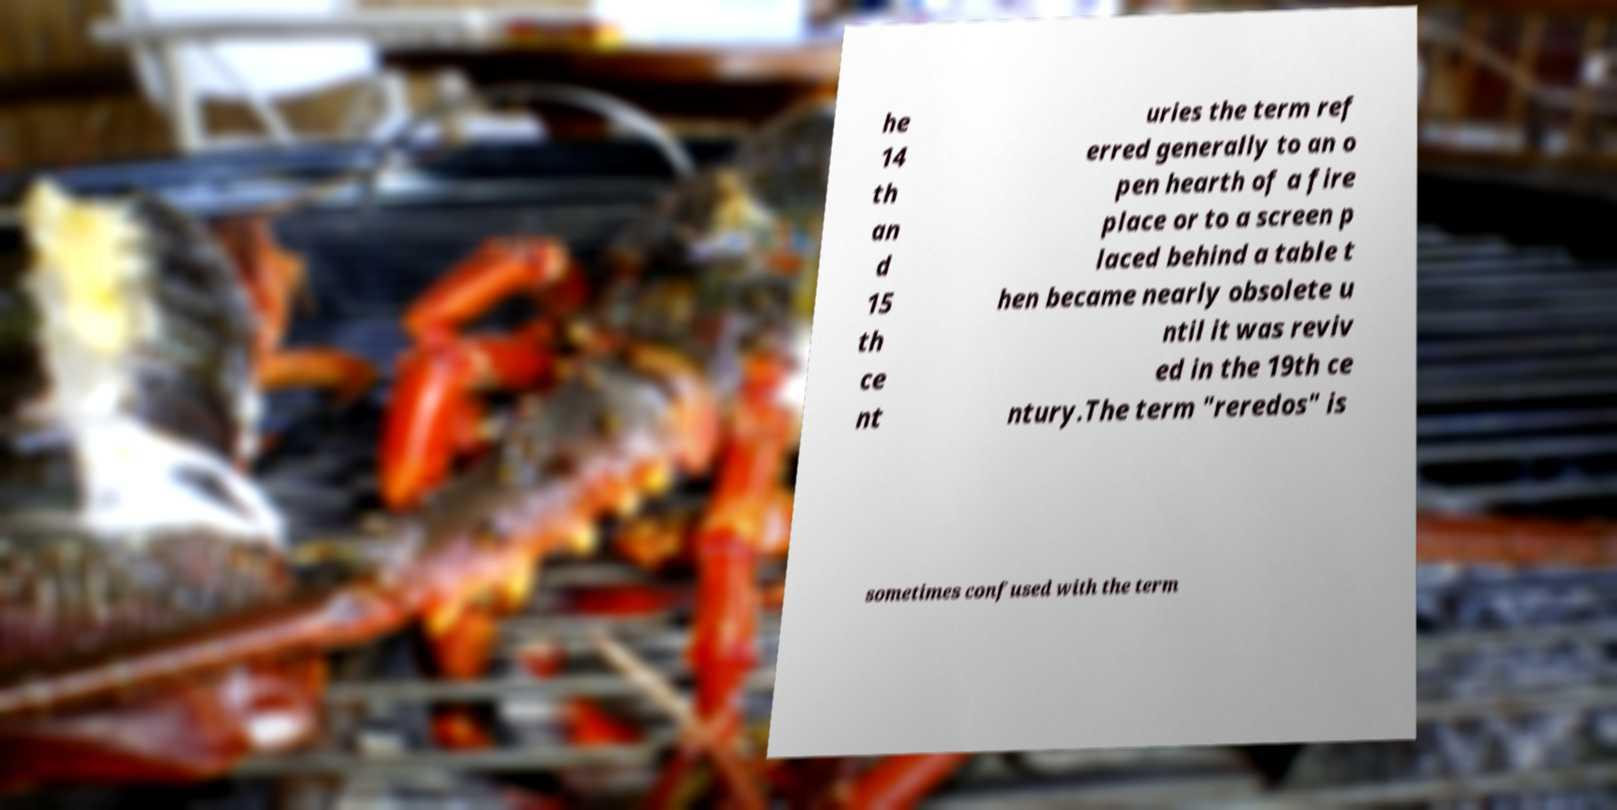What messages or text are displayed in this image? I need them in a readable, typed format. he 14 th an d 15 th ce nt uries the term ref erred generally to an o pen hearth of a fire place or to a screen p laced behind a table t hen became nearly obsolete u ntil it was reviv ed in the 19th ce ntury.The term "reredos" is sometimes confused with the term 